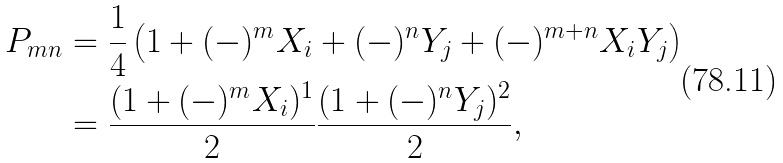<formula> <loc_0><loc_0><loc_500><loc_500>P _ { m n } & = \frac { 1 } { 4 } \left ( 1 + ( - ) ^ { m } X _ { i } + ( - ) ^ { n } Y _ { j } + ( - ) ^ { m + n } X _ { i } Y _ { j } \right ) \\ & = \frac { ( 1 + ( - ) ^ { m } X _ { i } ) ^ { 1 } } { 2 } \frac { ( 1 + ( - ) ^ { n } Y _ { j } ) ^ { 2 } } { 2 } ,</formula> 